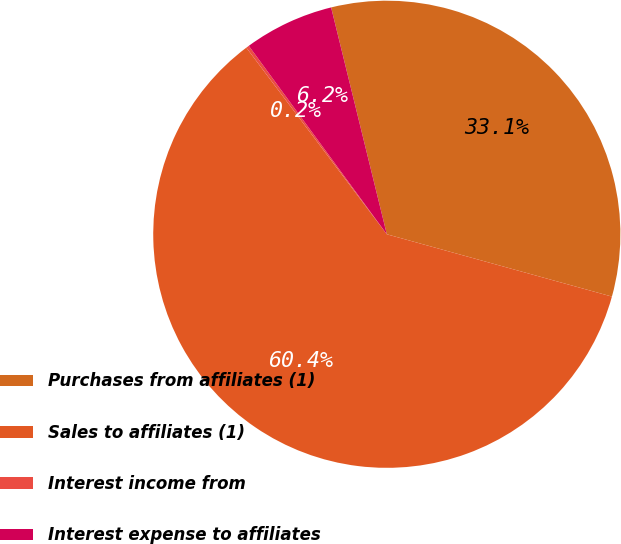<chart> <loc_0><loc_0><loc_500><loc_500><pie_chart><fcel>Purchases from affiliates (1)<fcel>Sales to affiliates (1)<fcel>Interest income from<fcel>Interest expense to affiliates<nl><fcel>33.13%<fcel>60.43%<fcel>0.21%<fcel>6.23%<nl></chart> 